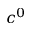<formula> <loc_0><loc_0><loc_500><loc_500>c ^ { 0 }</formula> 